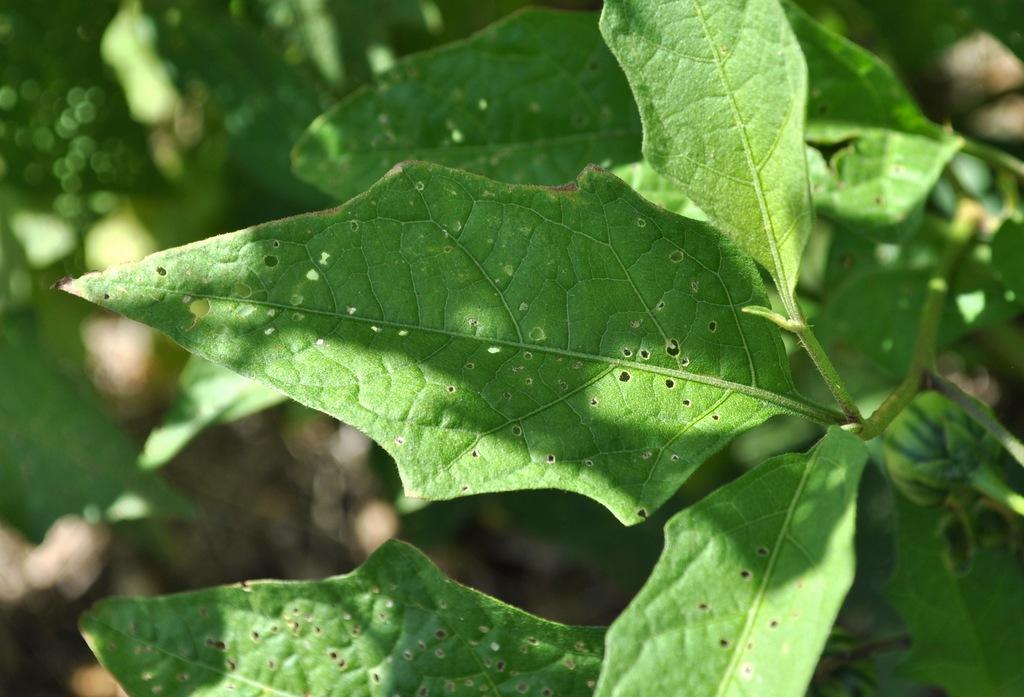Please provide a concise description of this image. In this image, we can see some plants. We can also see the blurred background. 